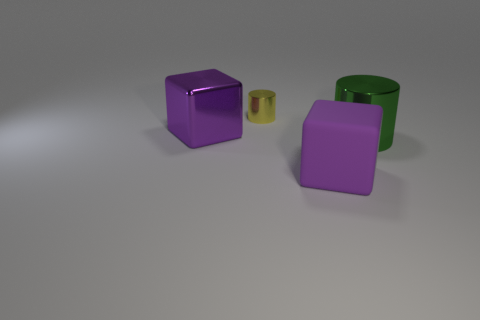What is the shape of the shiny thing that is the same color as the rubber cube?
Keep it short and to the point. Cube. What number of large things are cylinders or yellow cylinders?
Give a very brief answer. 1. Is the shape of the object that is in front of the green cylinder the same as  the tiny yellow object?
Ensure brevity in your answer.  No. Is the number of large green metallic things less than the number of objects?
Keep it short and to the point. Yes. Is there anything else of the same color as the rubber thing?
Offer a terse response. Yes. What shape is the large metal object that is on the right side of the small yellow cylinder?
Offer a terse response. Cylinder. There is a tiny cylinder; is it the same color as the big metal thing left of the purple matte thing?
Your answer should be very brief. No. Are there the same number of big metal things that are on the right side of the yellow metallic object and green things that are left of the big purple metallic thing?
Make the answer very short. No. What number of other things are there of the same size as the shiny cube?
Your answer should be compact. 2. What is the size of the purple rubber cube?
Your answer should be compact. Large. 